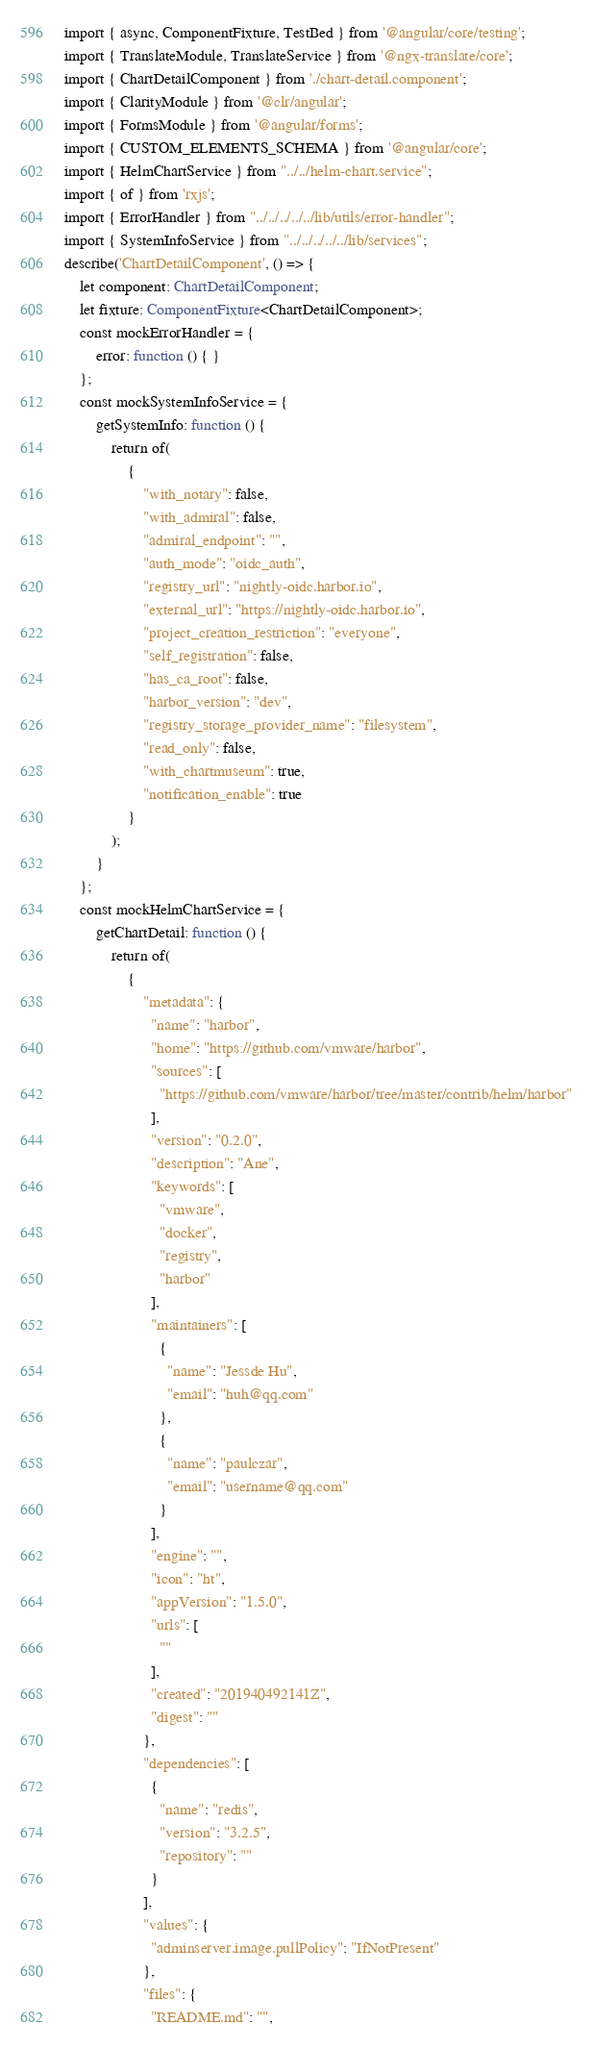<code> <loc_0><loc_0><loc_500><loc_500><_TypeScript_>import { async, ComponentFixture, TestBed } from '@angular/core/testing';
import { TranslateModule, TranslateService } from '@ngx-translate/core';
import { ChartDetailComponent } from './chart-detail.component';
import { ClarityModule } from '@clr/angular';
import { FormsModule } from '@angular/forms';
import { CUSTOM_ELEMENTS_SCHEMA } from '@angular/core';
import { HelmChartService } from "../../helm-chart.service";
import { of } from 'rxjs';
import { ErrorHandler } from "../../../../../lib/utils/error-handler";
import { SystemInfoService } from "../../../../../lib/services";
describe('ChartDetailComponent', () => {
    let component: ChartDetailComponent;
    let fixture: ComponentFixture<ChartDetailComponent>;
    const mockErrorHandler = {
        error: function () { }
    };
    const mockSystemInfoService = {
        getSystemInfo: function () {
            return of(
                {
                    "with_notary": false,
                    "with_admiral": false,
                    "admiral_endpoint": "",
                    "auth_mode": "oidc_auth",
                    "registry_url": "nightly-oidc.harbor.io",
                    "external_url": "https://nightly-oidc.harbor.io",
                    "project_creation_restriction": "everyone",
                    "self_registration": false,
                    "has_ca_root": false,
                    "harbor_version": "dev",
                    "registry_storage_provider_name": "filesystem",
                    "read_only": false,
                    "with_chartmuseum": true,
                    "notification_enable": true
                }
            );
        }
    };
    const mockHelmChartService = {
        getChartDetail: function () {
            return of(
                {
                    "metadata": {
                      "name": "harbor",
                      "home": "https://github.com/vmware/harbor",
                      "sources": [
                        "https://github.com/vmware/harbor/tree/master/contrib/helm/harbor"
                      ],
                      "version": "0.2.0",
                      "description": "Ane",
                      "keywords": [
                        "vmware",
                        "docker",
                        "registry",
                        "harbor"
                      ],
                      "maintainers": [
                        {
                          "name": "Jessde Hu",
                          "email": "huh@qq.com"
                        },
                        {
                          "name": "paulczar",
                          "email": "username@qq.com"
                        }
                      ],
                      "engine": "",
                      "icon": "ht",
                      "appVersion": "1.5.0",
                      "urls": [
                        ""
                      ],
                      "created": "201940492141Z",
                      "digest": ""
                    },
                    "dependencies": [
                      {
                        "name": "redis",
                        "version": "3.2.5",
                        "repository": ""
                      }
                    ],
                    "values": {
                      "adminserver.image.pullPolicy": "IfNotPresent"
                    },
                    "files": {
                      "README.md": "",</code> 